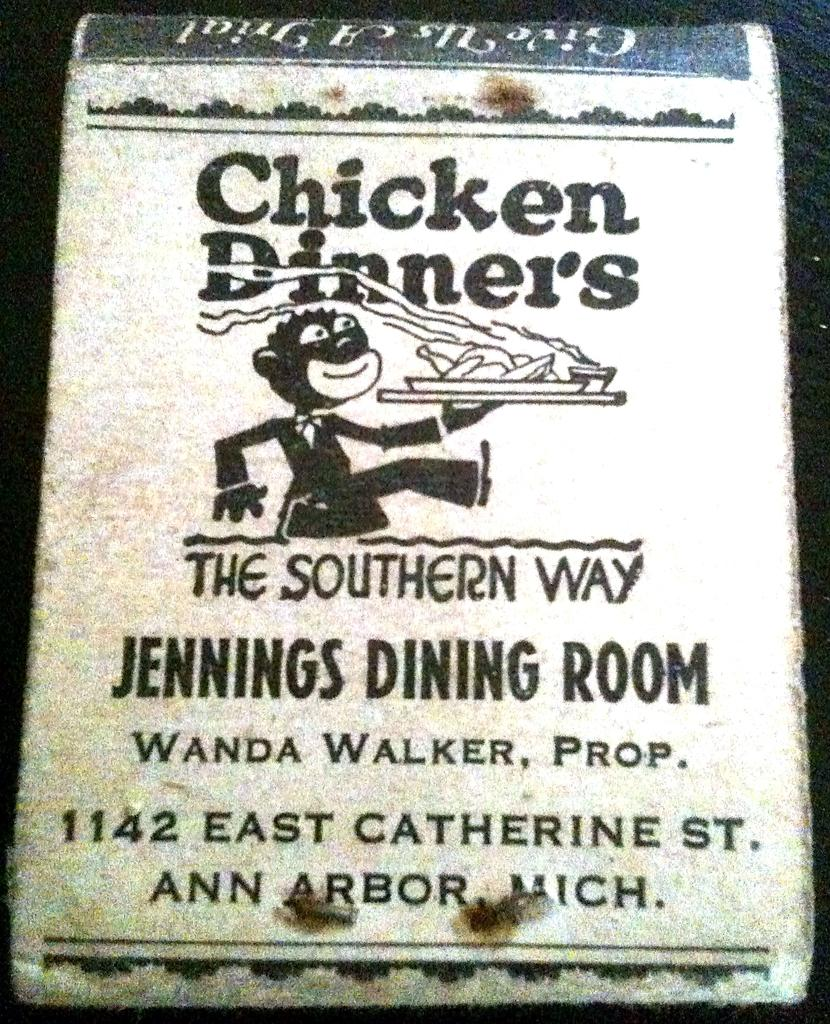Provide a one-sentence caption for the provided image. A Chicken Dinners pamphlet from Ann Arbor, Mich. 